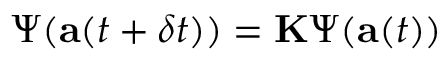Convert formula to latex. <formula><loc_0><loc_0><loc_500><loc_500>\Psi ( a ( t + \delta t ) ) = K \Psi ( a ( t ) )</formula> 